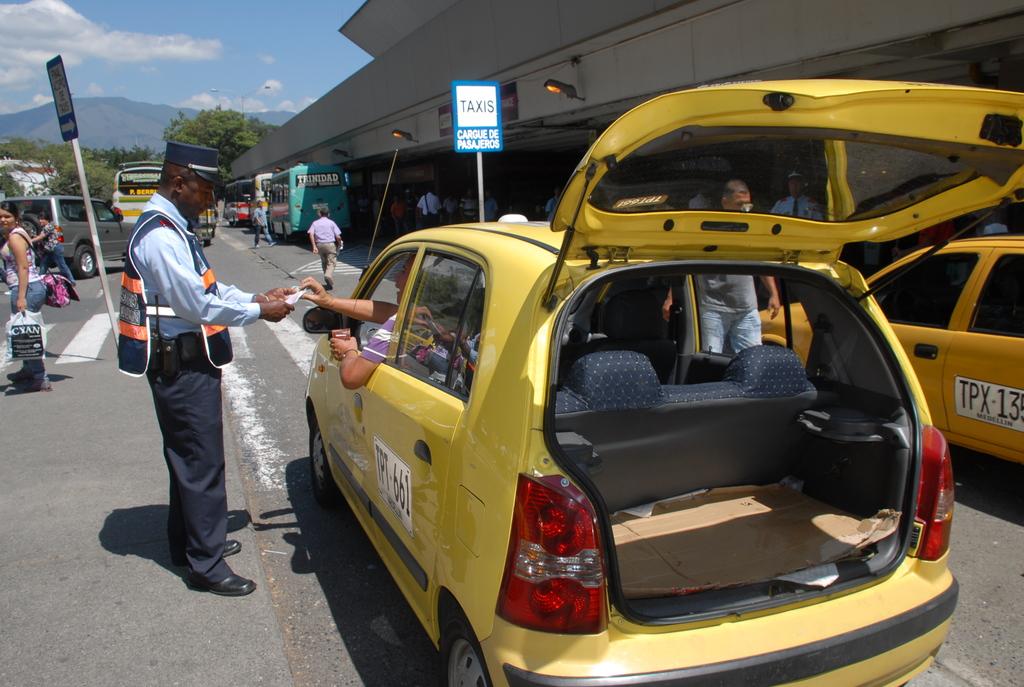What type of vehicle is written on the blue and white sign?
Provide a short and direct response. Taxis. What is the taxi number for the taxi in the middle?
Offer a very short reply. Tpx 135. 